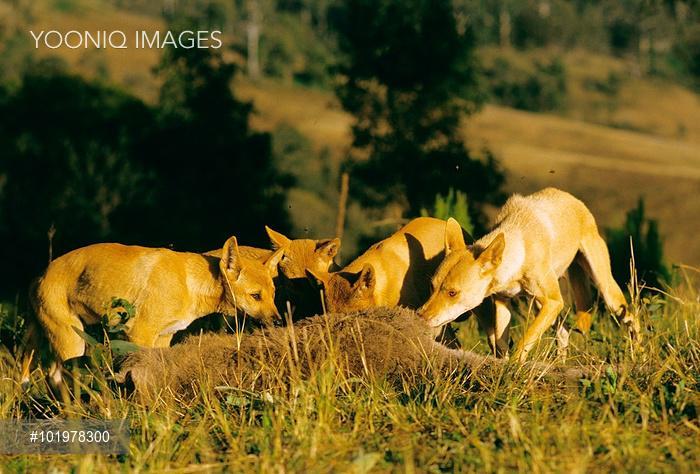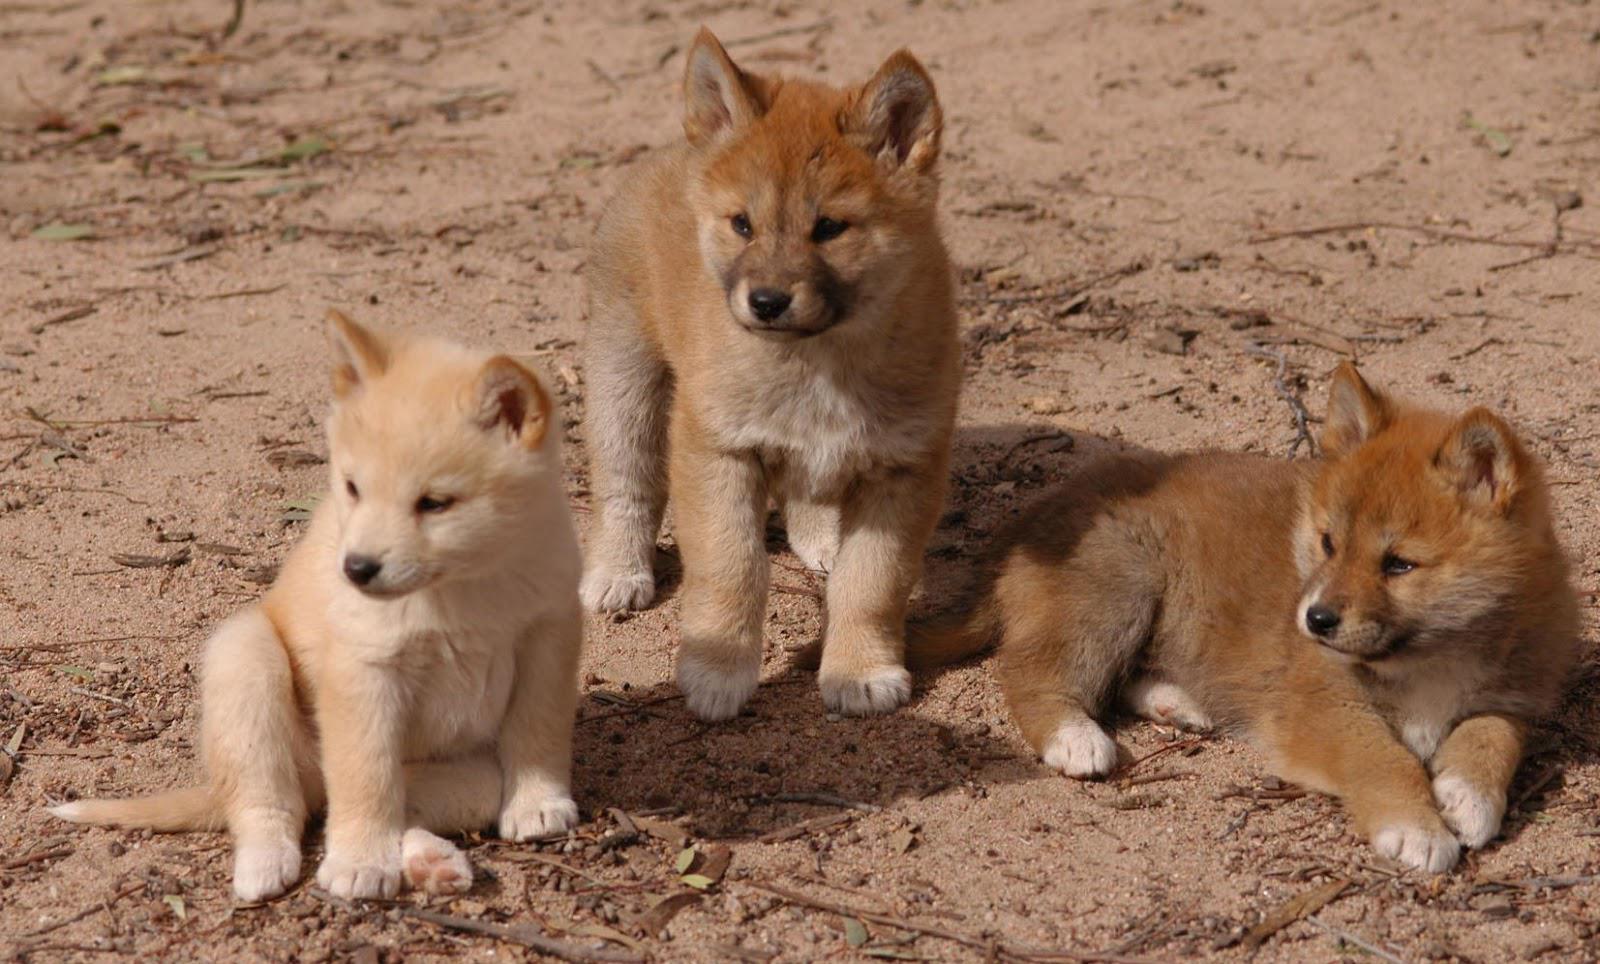The first image is the image on the left, the second image is the image on the right. Given the left and right images, does the statement "An image shows at least one dog standing by a carcass." hold true? Answer yes or no. Yes. 